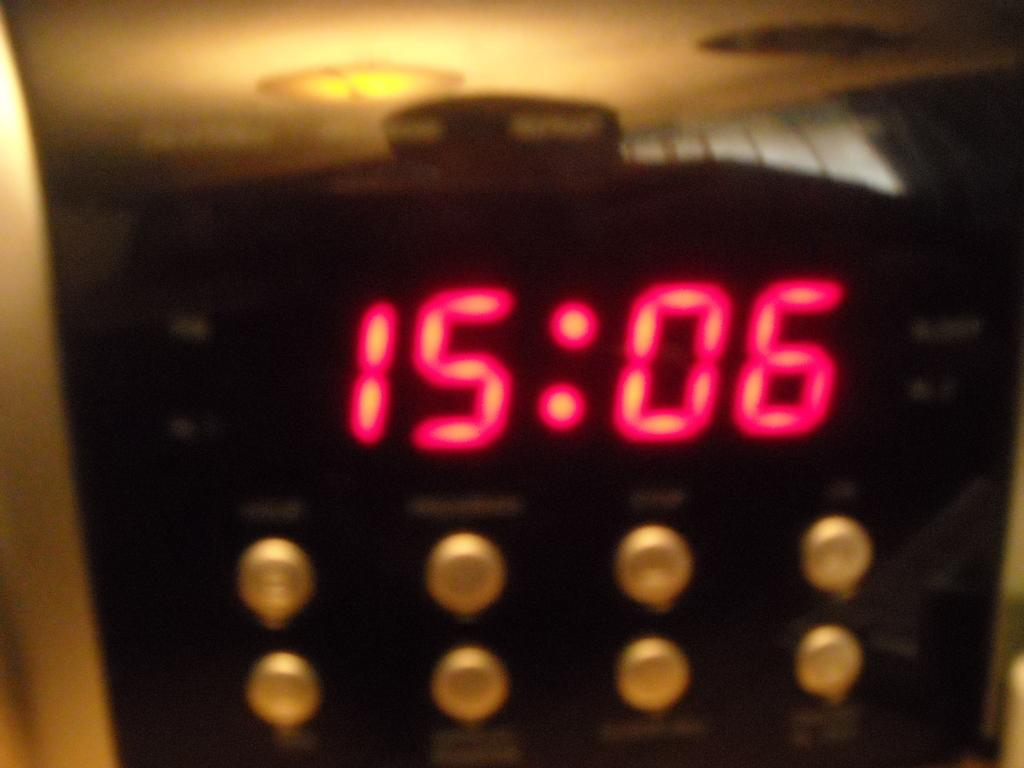<image>
Share a concise interpretation of the image provided. An electronic box with the digits 15:06 displayed in red. 